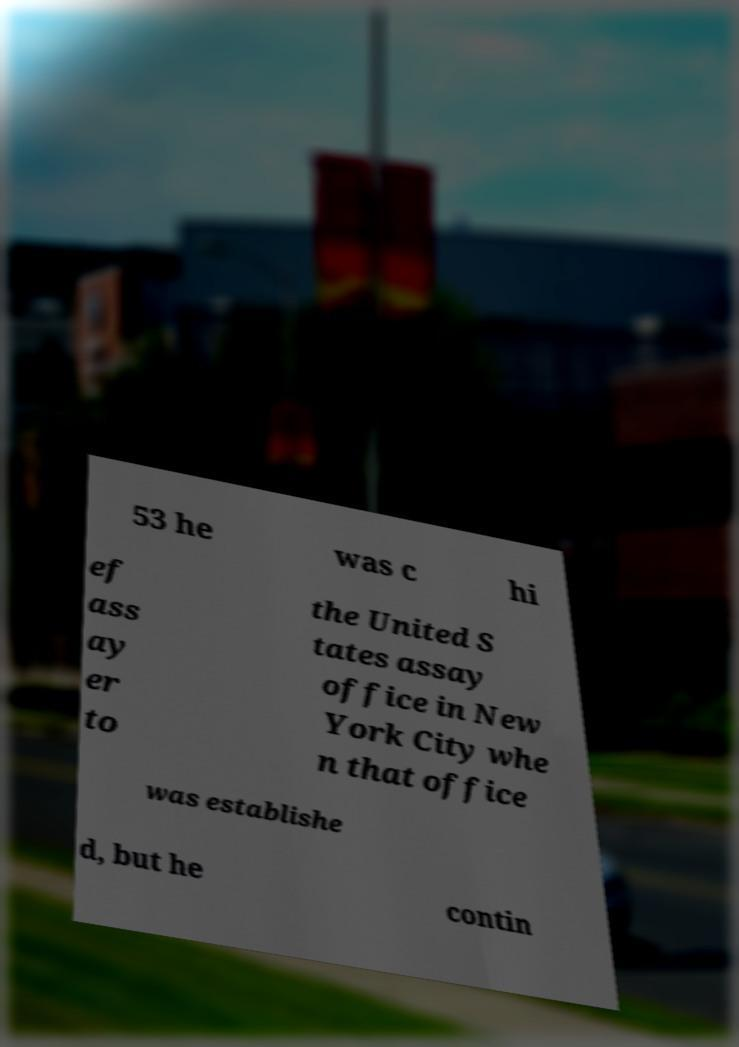For documentation purposes, I need the text within this image transcribed. Could you provide that? 53 he was c hi ef ass ay er to the United S tates assay office in New York City whe n that office was establishe d, but he contin 